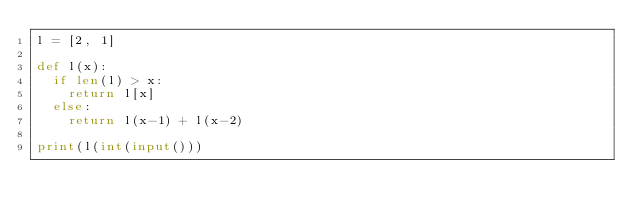<code> <loc_0><loc_0><loc_500><loc_500><_Python_>l = [2, 1]

def l(x):
  if len(l) > x:
    return l[x]
  else:
    return l(x-1) + l(x-2)
  
print(l(int(input()))</code> 